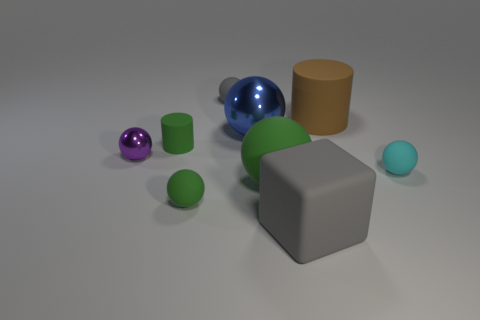Subtract all gray balls. How many balls are left? 5 Subtract all tiny green rubber balls. How many balls are left? 5 Subtract all brown balls. Subtract all yellow cylinders. How many balls are left? 6 Add 1 rubber blocks. How many objects exist? 10 Subtract all spheres. How many objects are left? 3 Add 4 big blue metallic spheres. How many big blue metallic spheres are left? 5 Add 4 big brown objects. How many big brown objects exist? 5 Subtract 1 blue balls. How many objects are left? 8 Subtract all tiny purple shiny objects. Subtract all small matte balls. How many objects are left? 5 